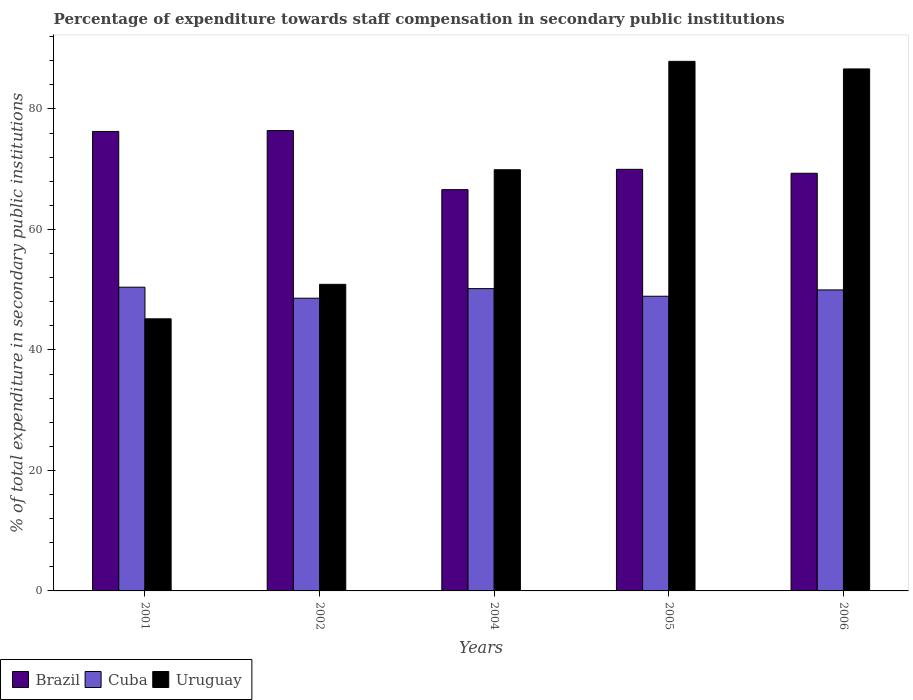How many groups of bars are there?
Keep it short and to the point. 5. Are the number of bars per tick equal to the number of legend labels?
Keep it short and to the point. Yes. What is the label of the 2nd group of bars from the left?
Your answer should be very brief. 2002. In how many cases, is the number of bars for a given year not equal to the number of legend labels?
Give a very brief answer. 0. What is the percentage of expenditure towards staff compensation in Uruguay in 2005?
Provide a short and direct response. 87.9. Across all years, what is the maximum percentage of expenditure towards staff compensation in Uruguay?
Provide a short and direct response. 87.9. Across all years, what is the minimum percentage of expenditure towards staff compensation in Uruguay?
Keep it short and to the point. 45.17. In which year was the percentage of expenditure towards staff compensation in Uruguay minimum?
Offer a terse response. 2001. What is the total percentage of expenditure towards staff compensation in Uruguay in the graph?
Your answer should be compact. 340.52. What is the difference between the percentage of expenditure towards staff compensation in Brazil in 2002 and that in 2006?
Provide a succinct answer. 7.08. What is the difference between the percentage of expenditure towards staff compensation in Cuba in 2001 and the percentage of expenditure towards staff compensation in Uruguay in 2002?
Give a very brief answer. -0.48. What is the average percentage of expenditure towards staff compensation in Brazil per year?
Give a very brief answer. 71.72. In the year 2004, what is the difference between the percentage of expenditure towards staff compensation in Uruguay and percentage of expenditure towards staff compensation in Brazil?
Offer a terse response. 3.31. In how many years, is the percentage of expenditure towards staff compensation in Uruguay greater than 16 %?
Give a very brief answer. 5. What is the ratio of the percentage of expenditure towards staff compensation in Cuba in 2005 to that in 2006?
Your response must be concise. 0.98. Is the percentage of expenditure towards staff compensation in Uruguay in 2001 less than that in 2002?
Your response must be concise. Yes. Is the difference between the percentage of expenditure towards staff compensation in Uruguay in 2004 and 2005 greater than the difference between the percentage of expenditure towards staff compensation in Brazil in 2004 and 2005?
Your response must be concise. No. What is the difference between the highest and the second highest percentage of expenditure towards staff compensation in Uruguay?
Your answer should be very brief. 1.26. What is the difference between the highest and the lowest percentage of expenditure towards staff compensation in Brazil?
Make the answer very short. 9.8. Is the sum of the percentage of expenditure towards staff compensation in Cuba in 2002 and 2006 greater than the maximum percentage of expenditure towards staff compensation in Uruguay across all years?
Offer a terse response. Yes. What does the 3rd bar from the left in 2001 represents?
Your response must be concise. Uruguay. How many years are there in the graph?
Your response must be concise. 5. What is the difference between two consecutive major ticks on the Y-axis?
Give a very brief answer. 20. Does the graph contain any zero values?
Make the answer very short. No. How are the legend labels stacked?
Your answer should be compact. Horizontal. What is the title of the graph?
Your response must be concise. Percentage of expenditure towards staff compensation in secondary public institutions. Does "North America" appear as one of the legend labels in the graph?
Your response must be concise. No. What is the label or title of the X-axis?
Provide a succinct answer. Years. What is the label or title of the Y-axis?
Keep it short and to the point. % of total expenditure in secondary public institutions. What is the % of total expenditure in secondary public institutions of Brazil in 2001?
Ensure brevity in your answer.  76.27. What is the % of total expenditure in secondary public institutions of Cuba in 2001?
Keep it short and to the point. 50.42. What is the % of total expenditure in secondary public institutions in Uruguay in 2001?
Make the answer very short. 45.17. What is the % of total expenditure in secondary public institutions of Brazil in 2002?
Your answer should be compact. 76.41. What is the % of total expenditure in secondary public institutions in Cuba in 2002?
Ensure brevity in your answer.  48.59. What is the % of total expenditure in secondary public institutions of Uruguay in 2002?
Keep it short and to the point. 50.89. What is the % of total expenditure in secondary public institutions of Brazil in 2004?
Your response must be concise. 66.61. What is the % of total expenditure in secondary public institutions of Cuba in 2004?
Your answer should be very brief. 50.18. What is the % of total expenditure in secondary public institutions in Uruguay in 2004?
Ensure brevity in your answer.  69.91. What is the % of total expenditure in secondary public institutions of Brazil in 2005?
Give a very brief answer. 69.98. What is the % of total expenditure in secondary public institutions in Cuba in 2005?
Offer a terse response. 48.92. What is the % of total expenditure in secondary public institutions of Uruguay in 2005?
Your answer should be compact. 87.9. What is the % of total expenditure in secondary public institutions in Brazil in 2006?
Your answer should be compact. 69.33. What is the % of total expenditure in secondary public institutions of Cuba in 2006?
Offer a terse response. 49.97. What is the % of total expenditure in secondary public institutions of Uruguay in 2006?
Keep it short and to the point. 86.65. Across all years, what is the maximum % of total expenditure in secondary public institutions of Brazil?
Your response must be concise. 76.41. Across all years, what is the maximum % of total expenditure in secondary public institutions of Cuba?
Your response must be concise. 50.42. Across all years, what is the maximum % of total expenditure in secondary public institutions in Uruguay?
Ensure brevity in your answer.  87.9. Across all years, what is the minimum % of total expenditure in secondary public institutions in Brazil?
Give a very brief answer. 66.61. Across all years, what is the minimum % of total expenditure in secondary public institutions in Cuba?
Offer a terse response. 48.59. Across all years, what is the minimum % of total expenditure in secondary public institutions of Uruguay?
Offer a terse response. 45.17. What is the total % of total expenditure in secondary public institutions in Brazil in the graph?
Ensure brevity in your answer.  358.59. What is the total % of total expenditure in secondary public institutions of Cuba in the graph?
Keep it short and to the point. 248.07. What is the total % of total expenditure in secondary public institutions in Uruguay in the graph?
Ensure brevity in your answer.  340.52. What is the difference between the % of total expenditure in secondary public institutions of Brazil in 2001 and that in 2002?
Keep it short and to the point. -0.14. What is the difference between the % of total expenditure in secondary public institutions of Cuba in 2001 and that in 2002?
Provide a short and direct response. 1.83. What is the difference between the % of total expenditure in secondary public institutions in Uruguay in 2001 and that in 2002?
Ensure brevity in your answer.  -5.72. What is the difference between the % of total expenditure in secondary public institutions of Brazil in 2001 and that in 2004?
Offer a very short reply. 9.66. What is the difference between the % of total expenditure in secondary public institutions in Cuba in 2001 and that in 2004?
Your answer should be compact. 0.24. What is the difference between the % of total expenditure in secondary public institutions of Uruguay in 2001 and that in 2004?
Keep it short and to the point. -24.75. What is the difference between the % of total expenditure in secondary public institutions in Brazil in 2001 and that in 2005?
Your answer should be compact. 6.29. What is the difference between the % of total expenditure in secondary public institutions of Cuba in 2001 and that in 2005?
Provide a short and direct response. 1.5. What is the difference between the % of total expenditure in secondary public institutions in Uruguay in 2001 and that in 2005?
Ensure brevity in your answer.  -42.74. What is the difference between the % of total expenditure in secondary public institutions in Brazil in 2001 and that in 2006?
Keep it short and to the point. 6.94. What is the difference between the % of total expenditure in secondary public institutions of Cuba in 2001 and that in 2006?
Ensure brevity in your answer.  0.45. What is the difference between the % of total expenditure in secondary public institutions in Uruguay in 2001 and that in 2006?
Make the answer very short. -41.48. What is the difference between the % of total expenditure in secondary public institutions of Brazil in 2002 and that in 2004?
Provide a short and direct response. 9.8. What is the difference between the % of total expenditure in secondary public institutions in Cuba in 2002 and that in 2004?
Your response must be concise. -1.59. What is the difference between the % of total expenditure in secondary public institutions of Uruguay in 2002 and that in 2004?
Your answer should be very brief. -19.02. What is the difference between the % of total expenditure in secondary public institutions in Brazil in 2002 and that in 2005?
Provide a short and direct response. 6.43. What is the difference between the % of total expenditure in secondary public institutions in Cuba in 2002 and that in 2005?
Your response must be concise. -0.33. What is the difference between the % of total expenditure in secondary public institutions of Uruguay in 2002 and that in 2005?
Give a very brief answer. -37.01. What is the difference between the % of total expenditure in secondary public institutions of Brazil in 2002 and that in 2006?
Offer a terse response. 7.08. What is the difference between the % of total expenditure in secondary public institutions of Cuba in 2002 and that in 2006?
Offer a very short reply. -1.38. What is the difference between the % of total expenditure in secondary public institutions of Uruguay in 2002 and that in 2006?
Your response must be concise. -35.76. What is the difference between the % of total expenditure in secondary public institutions of Brazil in 2004 and that in 2005?
Give a very brief answer. -3.37. What is the difference between the % of total expenditure in secondary public institutions in Cuba in 2004 and that in 2005?
Ensure brevity in your answer.  1.26. What is the difference between the % of total expenditure in secondary public institutions in Uruguay in 2004 and that in 2005?
Ensure brevity in your answer.  -17.99. What is the difference between the % of total expenditure in secondary public institutions of Brazil in 2004 and that in 2006?
Your answer should be very brief. -2.72. What is the difference between the % of total expenditure in secondary public institutions in Cuba in 2004 and that in 2006?
Your answer should be compact. 0.21. What is the difference between the % of total expenditure in secondary public institutions in Uruguay in 2004 and that in 2006?
Provide a succinct answer. -16.73. What is the difference between the % of total expenditure in secondary public institutions of Brazil in 2005 and that in 2006?
Your response must be concise. 0.65. What is the difference between the % of total expenditure in secondary public institutions in Cuba in 2005 and that in 2006?
Keep it short and to the point. -1.05. What is the difference between the % of total expenditure in secondary public institutions of Uruguay in 2005 and that in 2006?
Give a very brief answer. 1.26. What is the difference between the % of total expenditure in secondary public institutions in Brazil in 2001 and the % of total expenditure in secondary public institutions in Cuba in 2002?
Offer a terse response. 27.68. What is the difference between the % of total expenditure in secondary public institutions of Brazil in 2001 and the % of total expenditure in secondary public institutions of Uruguay in 2002?
Make the answer very short. 25.38. What is the difference between the % of total expenditure in secondary public institutions of Cuba in 2001 and the % of total expenditure in secondary public institutions of Uruguay in 2002?
Give a very brief answer. -0.48. What is the difference between the % of total expenditure in secondary public institutions in Brazil in 2001 and the % of total expenditure in secondary public institutions in Cuba in 2004?
Your answer should be compact. 26.09. What is the difference between the % of total expenditure in secondary public institutions in Brazil in 2001 and the % of total expenditure in secondary public institutions in Uruguay in 2004?
Give a very brief answer. 6.36. What is the difference between the % of total expenditure in secondary public institutions in Cuba in 2001 and the % of total expenditure in secondary public institutions in Uruguay in 2004?
Offer a terse response. -19.5. What is the difference between the % of total expenditure in secondary public institutions in Brazil in 2001 and the % of total expenditure in secondary public institutions in Cuba in 2005?
Your answer should be very brief. 27.35. What is the difference between the % of total expenditure in secondary public institutions in Brazil in 2001 and the % of total expenditure in secondary public institutions in Uruguay in 2005?
Provide a short and direct response. -11.63. What is the difference between the % of total expenditure in secondary public institutions in Cuba in 2001 and the % of total expenditure in secondary public institutions in Uruguay in 2005?
Provide a succinct answer. -37.49. What is the difference between the % of total expenditure in secondary public institutions of Brazil in 2001 and the % of total expenditure in secondary public institutions of Cuba in 2006?
Your answer should be very brief. 26.31. What is the difference between the % of total expenditure in secondary public institutions of Brazil in 2001 and the % of total expenditure in secondary public institutions of Uruguay in 2006?
Provide a succinct answer. -10.38. What is the difference between the % of total expenditure in secondary public institutions in Cuba in 2001 and the % of total expenditure in secondary public institutions in Uruguay in 2006?
Your response must be concise. -36.23. What is the difference between the % of total expenditure in secondary public institutions of Brazil in 2002 and the % of total expenditure in secondary public institutions of Cuba in 2004?
Keep it short and to the point. 26.23. What is the difference between the % of total expenditure in secondary public institutions of Brazil in 2002 and the % of total expenditure in secondary public institutions of Uruguay in 2004?
Provide a short and direct response. 6.49. What is the difference between the % of total expenditure in secondary public institutions of Cuba in 2002 and the % of total expenditure in secondary public institutions of Uruguay in 2004?
Your response must be concise. -21.33. What is the difference between the % of total expenditure in secondary public institutions in Brazil in 2002 and the % of total expenditure in secondary public institutions in Cuba in 2005?
Provide a succinct answer. 27.49. What is the difference between the % of total expenditure in secondary public institutions in Brazil in 2002 and the % of total expenditure in secondary public institutions in Uruguay in 2005?
Keep it short and to the point. -11.5. What is the difference between the % of total expenditure in secondary public institutions in Cuba in 2002 and the % of total expenditure in secondary public institutions in Uruguay in 2005?
Give a very brief answer. -39.32. What is the difference between the % of total expenditure in secondary public institutions of Brazil in 2002 and the % of total expenditure in secondary public institutions of Cuba in 2006?
Your answer should be compact. 26.44. What is the difference between the % of total expenditure in secondary public institutions in Brazil in 2002 and the % of total expenditure in secondary public institutions in Uruguay in 2006?
Your response must be concise. -10.24. What is the difference between the % of total expenditure in secondary public institutions in Cuba in 2002 and the % of total expenditure in secondary public institutions in Uruguay in 2006?
Provide a short and direct response. -38.06. What is the difference between the % of total expenditure in secondary public institutions of Brazil in 2004 and the % of total expenditure in secondary public institutions of Cuba in 2005?
Provide a short and direct response. 17.69. What is the difference between the % of total expenditure in secondary public institutions of Brazil in 2004 and the % of total expenditure in secondary public institutions of Uruguay in 2005?
Your answer should be very brief. -21.3. What is the difference between the % of total expenditure in secondary public institutions in Cuba in 2004 and the % of total expenditure in secondary public institutions in Uruguay in 2005?
Your answer should be compact. -37.72. What is the difference between the % of total expenditure in secondary public institutions of Brazil in 2004 and the % of total expenditure in secondary public institutions of Cuba in 2006?
Offer a very short reply. 16.64. What is the difference between the % of total expenditure in secondary public institutions of Brazil in 2004 and the % of total expenditure in secondary public institutions of Uruguay in 2006?
Provide a short and direct response. -20.04. What is the difference between the % of total expenditure in secondary public institutions in Cuba in 2004 and the % of total expenditure in secondary public institutions in Uruguay in 2006?
Offer a very short reply. -36.47. What is the difference between the % of total expenditure in secondary public institutions in Brazil in 2005 and the % of total expenditure in secondary public institutions in Cuba in 2006?
Ensure brevity in your answer.  20.01. What is the difference between the % of total expenditure in secondary public institutions in Brazil in 2005 and the % of total expenditure in secondary public institutions in Uruguay in 2006?
Give a very brief answer. -16.67. What is the difference between the % of total expenditure in secondary public institutions of Cuba in 2005 and the % of total expenditure in secondary public institutions of Uruguay in 2006?
Ensure brevity in your answer.  -37.73. What is the average % of total expenditure in secondary public institutions of Brazil per year?
Provide a succinct answer. 71.72. What is the average % of total expenditure in secondary public institutions of Cuba per year?
Give a very brief answer. 49.61. What is the average % of total expenditure in secondary public institutions in Uruguay per year?
Offer a very short reply. 68.1. In the year 2001, what is the difference between the % of total expenditure in secondary public institutions in Brazil and % of total expenditure in secondary public institutions in Cuba?
Offer a terse response. 25.86. In the year 2001, what is the difference between the % of total expenditure in secondary public institutions in Brazil and % of total expenditure in secondary public institutions in Uruguay?
Make the answer very short. 31.11. In the year 2001, what is the difference between the % of total expenditure in secondary public institutions in Cuba and % of total expenditure in secondary public institutions in Uruguay?
Ensure brevity in your answer.  5.25. In the year 2002, what is the difference between the % of total expenditure in secondary public institutions in Brazil and % of total expenditure in secondary public institutions in Cuba?
Your answer should be compact. 27.82. In the year 2002, what is the difference between the % of total expenditure in secondary public institutions in Brazil and % of total expenditure in secondary public institutions in Uruguay?
Ensure brevity in your answer.  25.52. In the year 2002, what is the difference between the % of total expenditure in secondary public institutions of Cuba and % of total expenditure in secondary public institutions of Uruguay?
Offer a very short reply. -2.3. In the year 2004, what is the difference between the % of total expenditure in secondary public institutions of Brazil and % of total expenditure in secondary public institutions of Cuba?
Your answer should be compact. 16.43. In the year 2004, what is the difference between the % of total expenditure in secondary public institutions of Brazil and % of total expenditure in secondary public institutions of Uruguay?
Your response must be concise. -3.31. In the year 2004, what is the difference between the % of total expenditure in secondary public institutions of Cuba and % of total expenditure in secondary public institutions of Uruguay?
Offer a very short reply. -19.73. In the year 2005, what is the difference between the % of total expenditure in secondary public institutions of Brazil and % of total expenditure in secondary public institutions of Cuba?
Give a very brief answer. 21.06. In the year 2005, what is the difference between the % of total expenditure in secondary public institutions of Brazil and % of total expenditure in secondary public institutions of Uruguay?
Ensure brevity in your answer.  -17.92. In the year 2005, what is the difference between the % of total expenditure in secondary public institutions of Cuba and % of total expenditure in secondary public institutions of Uruguay?
Your answer should be very brief. -38.99. In the year 2006, what is the difference between the % of total expenditure in secondary public institutions in Brazil and % of total expenditure in secondary public institutions in Cuba?
Your answer should be very brief. 19.36. In the year 2006, what is the difference between the % of total expenditure in secondary public institutions in Brazil and % of total expenditure in secondary public institutions in Uruguay?
Ensure brevity in your answer.  -17.32. In the year 2006, what is the difference between the % of total expenditure in secondary public institutions in Cuba and % of total expenditure in secondary public institutions in Uruguay?
Offer a very short reply. -36.68. What is the ratio of the % of total expenditure in secondary public institutions of Brazil in 2001 to that in 2002?
Keep it short and to the point. 1. What is the ratio of the % of total expenditure in secondary public institutions of Cuba in 2001 to that in 2002?
Give a very brief answer. 1.04. What is the ratio of the % of total expenditure in secondary public institutions in Uruguay in 2001 to that in 2002?
Offer a terse response. 0.89. What is the ratio of the % of total expenditure in secondary public institutions in Brazil in 2001 to that in 2004?
Offer a terse response. 1.15. What is the ratio of the % of total expenditure in secondary public institutions in Uruguay in 2001 to that in 2004?
Provide a succinct answer. 0.65. What is the ratio of the % of total expenditure in secondary public institutions in Brazil in 2001 to that in 2005?
Give a very brief answer. 1.09. What is the ratio of the % of total expenditure in secondary public institutions in Cuba in 2001 to that in 2005?
Your answer should be very brief. 1.03. What is the ratio of the % of total expenditure in secondary public institutions in Uruguay in 2001 to that in 2005?
Your answer should be very brief. 0.51. What is the ratio of the % of total expenditure in secondary public institutions in Brazil in 2001 to that in 2006?
Provide a short and direct response. 1.1. What is the ratio of the % of total expenditure in secondary public institutions of Cuba in 2001 to that in 2006?
Your answer should be very brief. 1.01. What is the ratio of the % of total expenditure in secondary public institutions of Uruguay in 2001 to that in 2006?
Offer a terse response. 0.52. What is the ratio of the % of total expenditure in secondary public institutions of Brazil in 2002 to that in 2004?
Ensure brevity in your answer.  1.15. What is the ratio of the % of total expenditure in secondary public institutions of Cuba in 2002 to that in 2004?
Offer a very short reply. 0.97. What is the ratio of the % of total expenditure in secondary public institutions in Uruguay in 2002 to that in 2004?
Give a very brief answer. 0.73. What is the ratio of the % of total expenditure in secondary public institutions in Brazil in 2002 to that in 2005?
Your response must be concise. 1.09. What is the ratio of the % of total expenditure in secondary public institutions of Uruguay in 2002 to that in 2005?
Provide a short and direct response. 0.58. What is the ratio of the % of total expenditure in secondary public institutions in Brazil in 2002 to that in 2006?
Offer a very short reply. 1.1. What is the ratio of the % of total expenditure in secondary public institutions of Cuba in 2002 to that in 2006?
Ensure brevity in your answer.  0.97. What is the ratio of the % of total expenditure in secondary public institutions of Uruguay in 2002 to that in 2006?
Give a very brief answer. 0.59. What is the ratio of the % of total expenditure in secondary public institutions in Brazil in 2004 to that in 2005?
Your answer should be compact. 0.95. What is the ratio of the % of total expenditure in secondary public institutions of Cuba in 2004 to that in 2005?
Keep it short and to the point. 1.03. What is the ratio of the % of total expenditure in secondary public institutions of Uruguay in 2004 to that in 2005?
Your answer should be very brief. 0.8. What is the ratio of the % of total expenditure in secondary public institutions of Brazil in 2004 to that in 2006?
Your answer should be very brief. 0.96. What is the ratio of the % of total expenditure in secondary public institutions of Uruguay in 2004 to that in 2006?
Your answer should be compact. 0.81. What is the ratio of the % of total expenditure in secondary public institutions of Brazil in 2005 to that in 2006?
Offer a very short reply. 1.01. What is the ratio of the % of total expenditure in secondary public institutions in Uruguay in 2005 to that in 2006?
Keep it short and to the point. 1.01. What is the difference between the highest and the second highest % of total expenditure in secondary public institutions of Brazil?
Offer a terse response. 0.14. What is the difference between the highest and the second highest % of total expenditure in secondary public institutions in Cuba?
Give a very brief answer. 0.24. What is the difference between the highest and the second highest % of total expenditure in secondary public institutions in Uruguay?
Provide a short and direct response. 1.26. What is the difference between the highest and the lowest % of total expenditure in secondary public institutions of Brazil?
Your answer should be compact. 9.8. What is the difference between the highest and the lowest % of total expenditure in secondary public institutions of Cuba?
Offer a terse response. 1.83. What is the difference between the highest and the lowest % of total expenditure in secondary public institutions of Uruguay?
Your response must be concise. 42.74. 